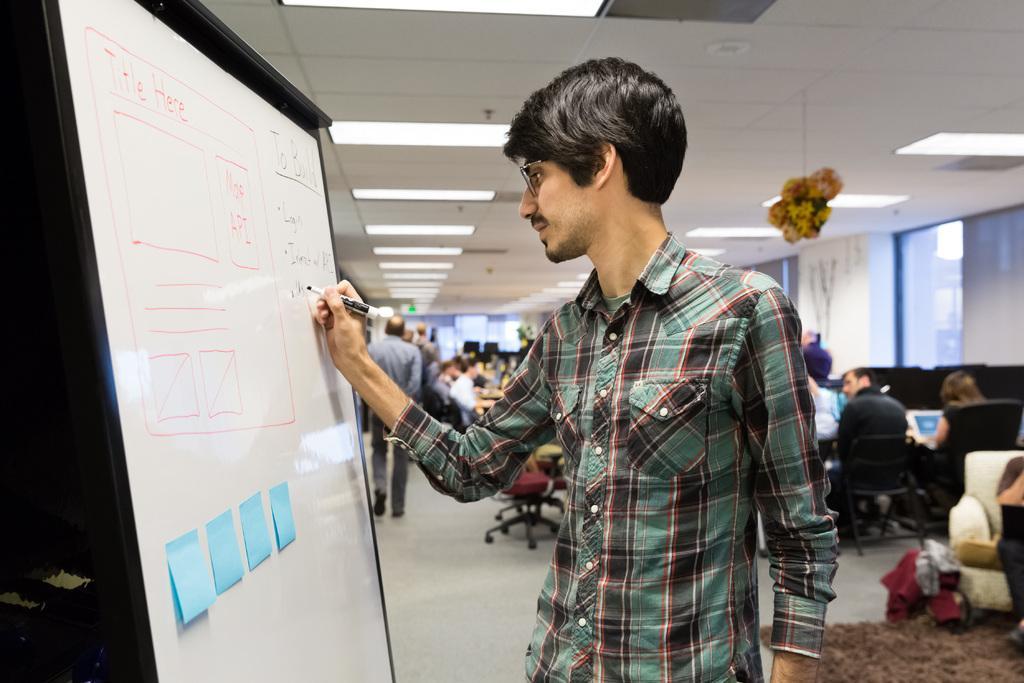Please provide a concise description of this image. In this image, I can see a person standing and writing on a whiteboard. In the background, there are few people standing, few people sitting on the chairs and there are glass windows. At the bottom right side of the image, I can see a bag and a carpet on the floor. At the top of the image, I can see the ceiling lights and a decorative item hanging to the ceiling. 